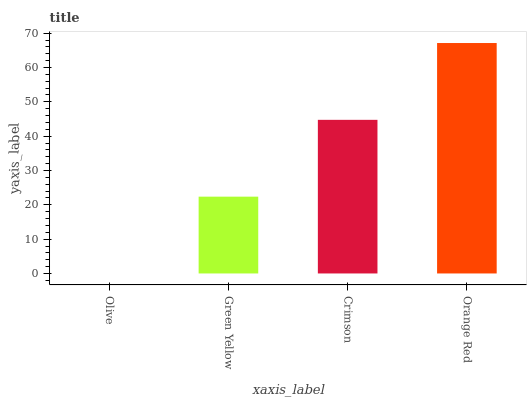Is Olive the minimum?
Answer yes or no. Yes. Is Orange Red the maximum?
Answer yes or no. Yes. Is Green Yellow the minimum?
Answer yes or no. No. Is Green Yellow the maximum?
Answer yes or no. No. Is Green Yellow greater than Olive?
Answer yes or no. Yes. Is Olive less than Green Yellow?
Answer yes or no. Yes. Is Olive greater than Green Yellow?
Answer yes or no. No. Is Green Yellow less than Olive?
Answer yes or no. No. Is Crimson the high median?
Answer yes or no. Yes. Is Green Yellow the low median?
Answer yes or no. Yes. Is Green Yellow the high median?
Answer yes or no. No. Is Olive the low median?
Answer yes or no. No. 